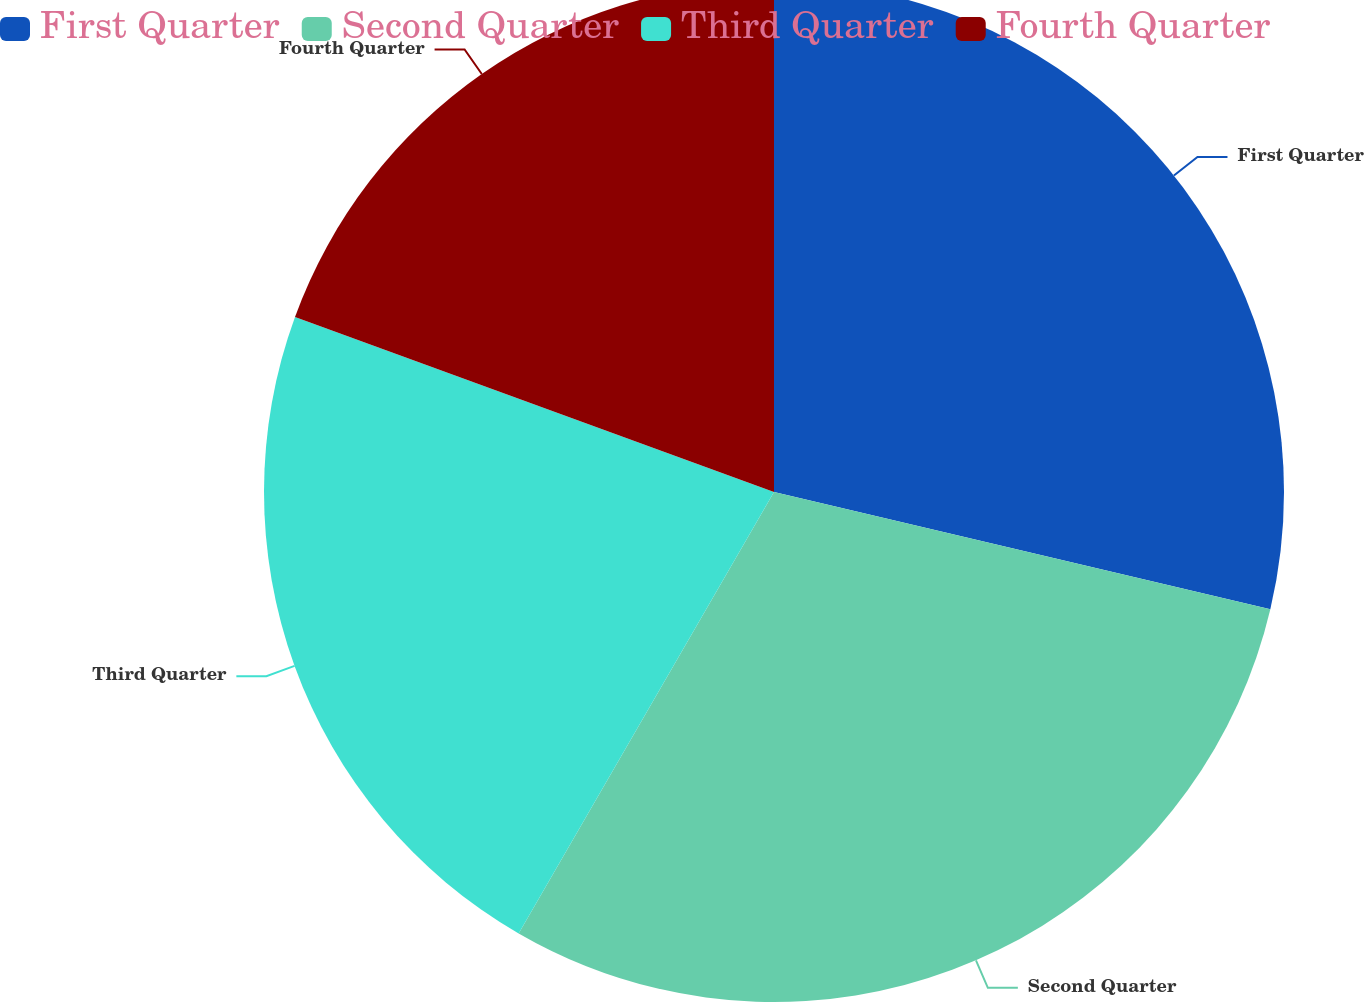<chart> <loc_0><loc_0><loc_500><loc_500><pie_chart><fcel>First Quarter<fcel>Second Quarter<fcel>Third Quarter<fcel>Fourth Quarter<nl><fcel>28.69%<fcel>29.65%<fcel>22.23%<fcel>19.42%<nl></chart> 